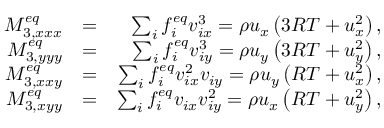Convert formula to latex. <formula><loc_0><loc_0><loc_500><loc_500>\begin{array} { r l r } { M _ { 3 , x x x } ^ { e q } } & { = } & { \sum _ { i } { f _ { i } ^ { e q } v _ { i x } ^ { 3 } } = \rho { u _ { x } } \left ( { 3 R T + u _ { x } ^ { 2 } } \right ) , } \\ { M _ { 3 , y y y } ^ { e q } } & { = } & { \sum _ { i } { f _ { i } ^ { e q } v _ { i y } ^ { 3 } } = \rho { u _ { y } } \left ( { 3 R T + u _ { y } ^ { 2 } } \right ) , } \\ { M _ { 3 , x x y } ^ { e q } } & { = } & { \sum _ { i } { f _ { i } ^ { e q } v _ { i x } ^ { 2 } { v _ { i y } } } = \rho { u _ { y } } \left ( { R T + u _ { x } ^ { 2 } } \right ) , } \\ { M _ { 3 , x y y } ^ { e q } } & { = } & { \sum _ { i } { f _ { i } ^ { e q } { v _ { i x } } v _ { i y } ^ { 2 } } = \rho { u _ { x } } \left ( { R T + u _ { y } ^ { 2 } } \right ) , } \end{array}</formula> 